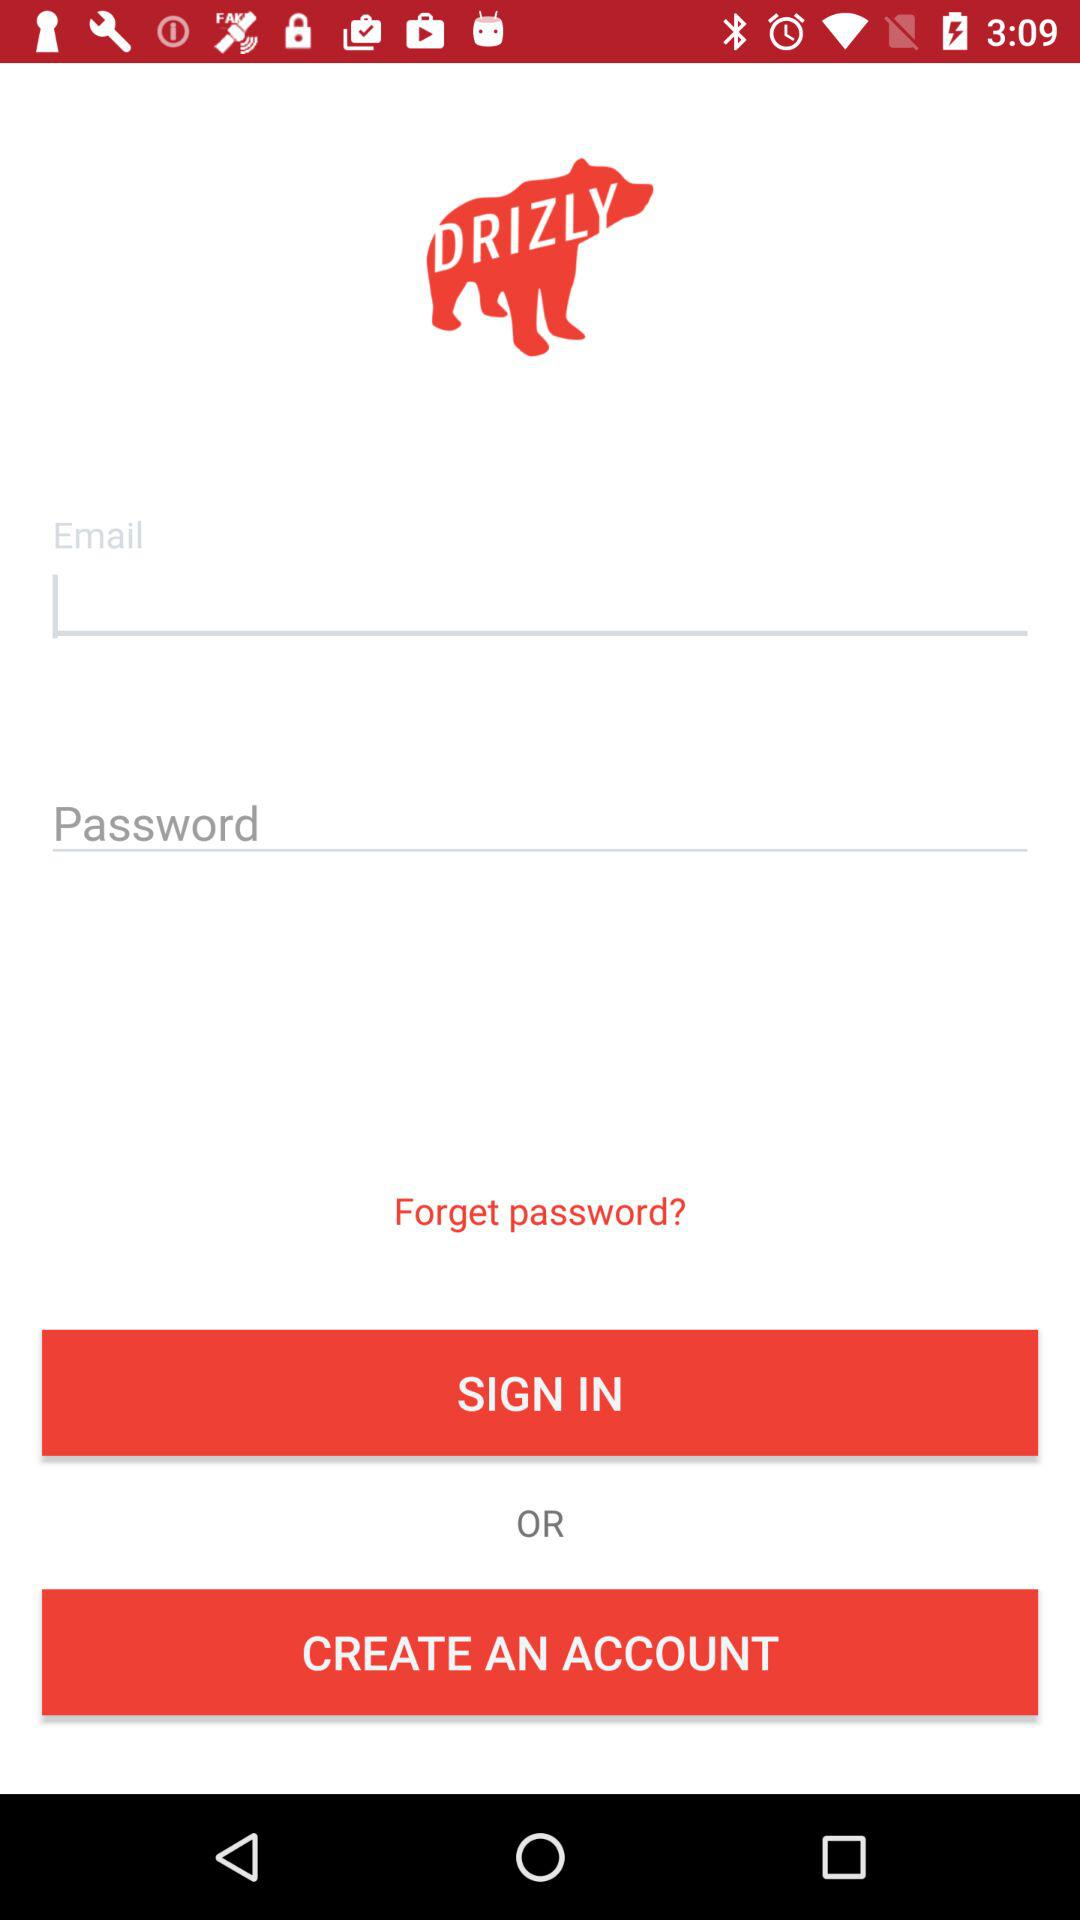What is the application name? The application name is "DRIZLY". 